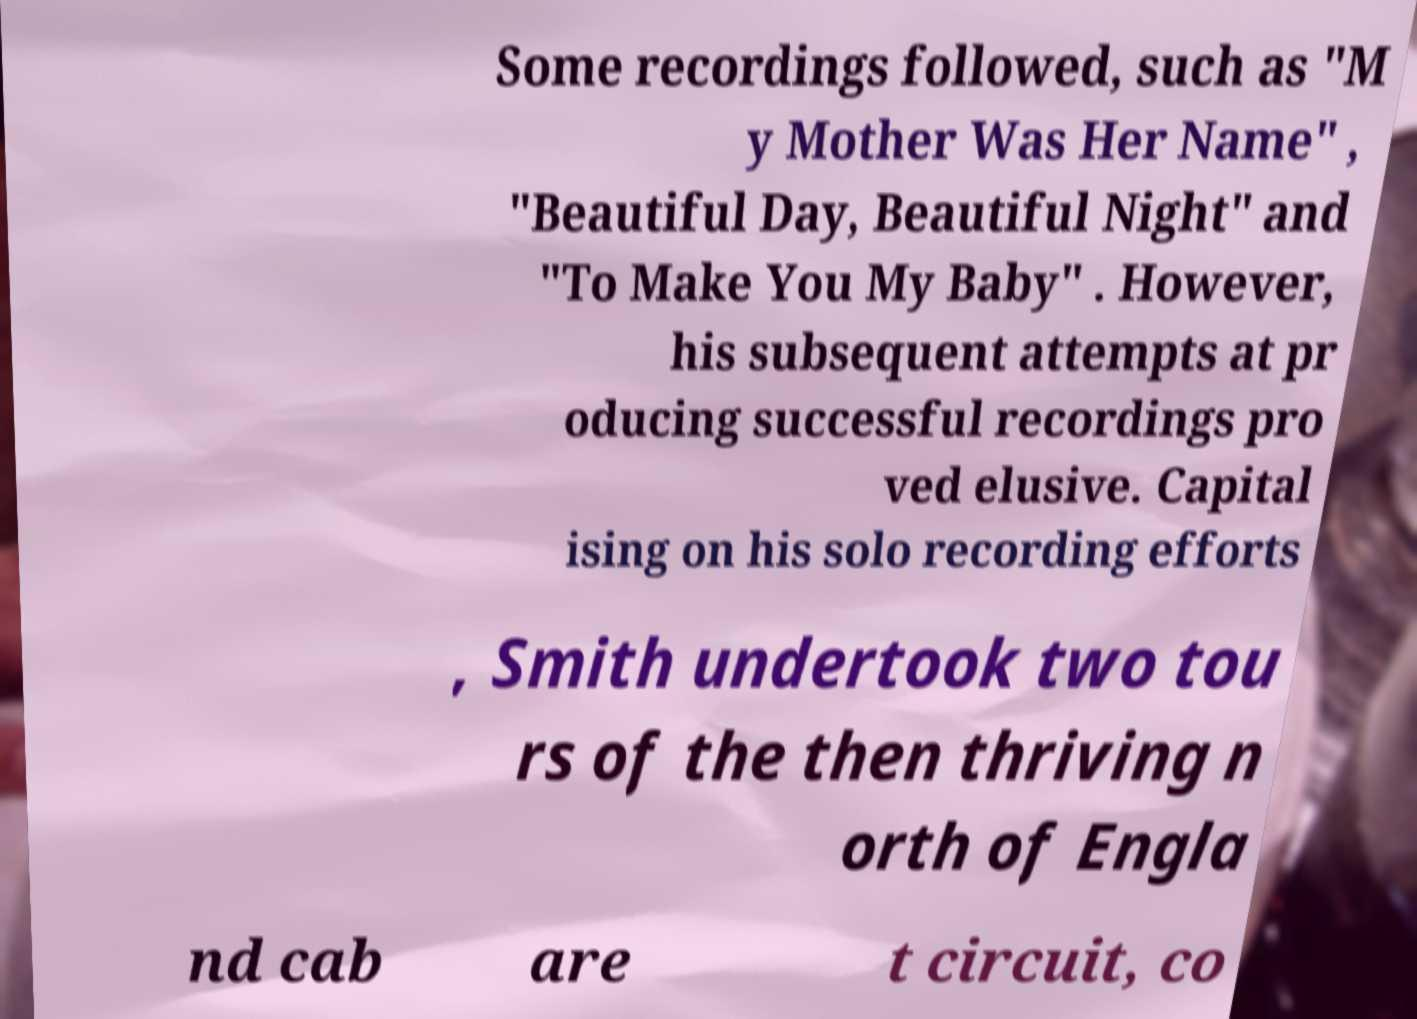There's text embedded in this image that I need extracted. Can you transcribe it verbatim? Some recordings followed, such as "M y Mother Was Her Name" , "Beautiful Day, Beautiful Night" and "To Make You My Baby" . However, his subsequent attempts at pr oducing successful recordings pro ved elusive. Capital ising on his solo recording efforts , Smith undertook two tou rs of the then thriving n orth of Engla nd cab are t circuit, co 